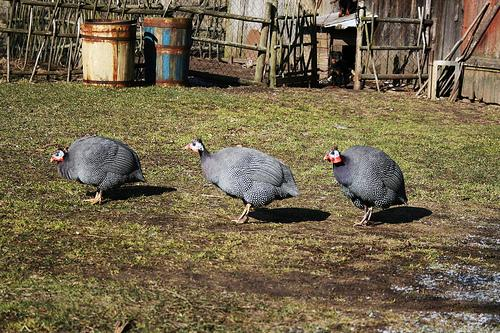What is the brown areas on the barrels? rust 